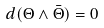<formula> <loc_0><loc_0><loc_500><loc_500>d ( \Theta \wedge \bar { \Theta } ) = 0</formula> 